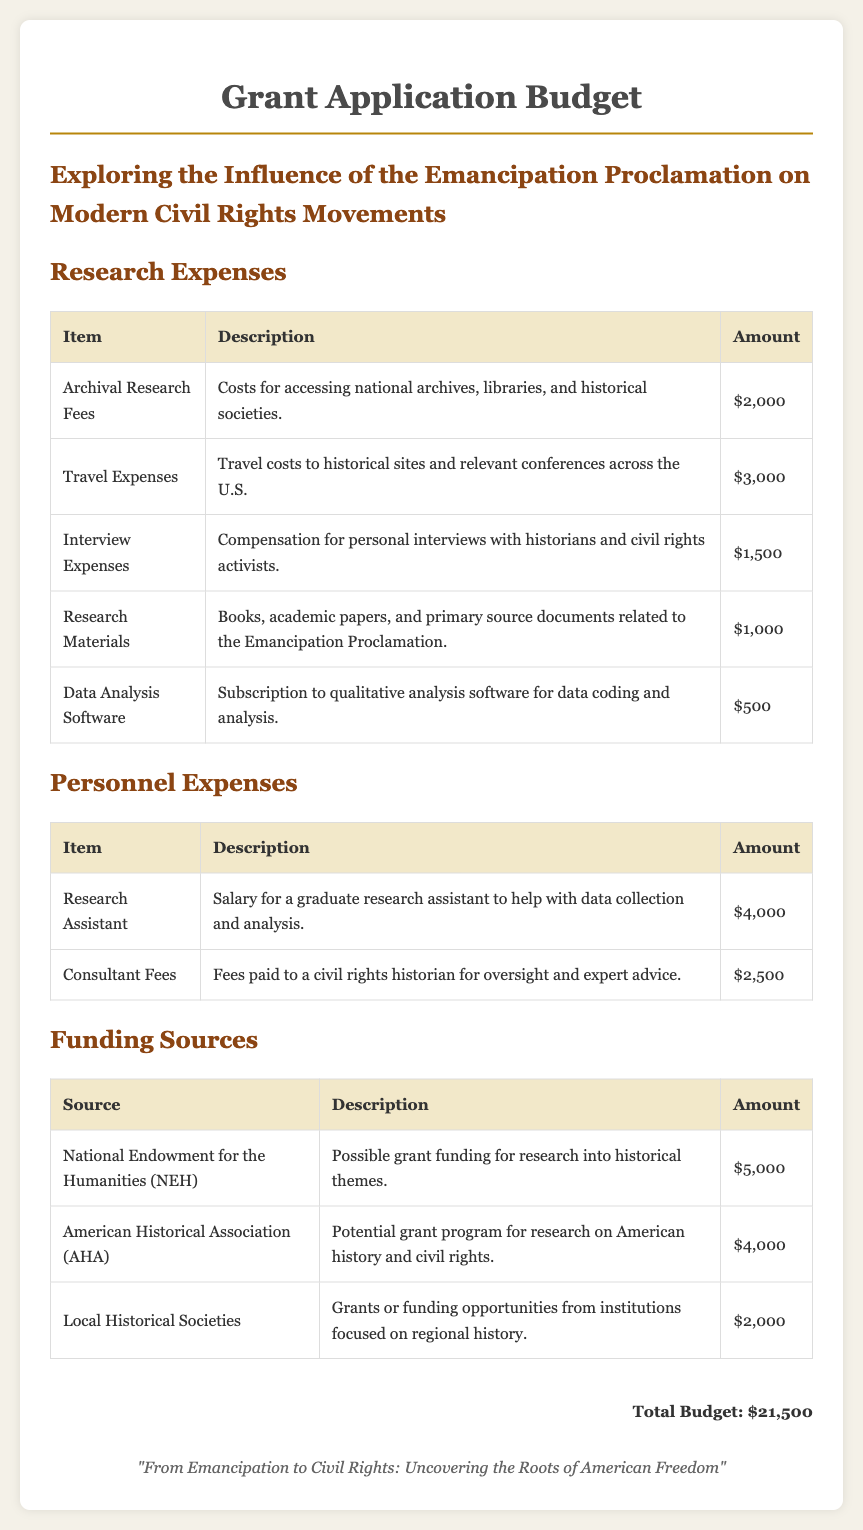What is the total budget? The total budget is presented at the bottom of the document and totals all expenses listed.
Answer: $21,500 How much is allocated for travel expenses? The travel expenses section lists costs associated with travel, which is detailed in that segment.
Answer: $3,000 What is the amount listed for archival research fees? The archival research fees are specifically mentioned as a cost in the research expenses table.
Answer: $2,000 Which funding source is associated with the American Historical Association? The document specifies the funding source and corresponding grants available through the AHA.
Answer: $4,000 How much is the salary for the research assistant? The personnel expenses section breaks down the salary allocations, including that for the research assistant.
Answer: $4,000 What is the amount earmarked for data analysis software? This expense is clearly itemized under research expenses in the budget table.
Answer: $500 How much is budgeted for consultant fees? The consultant fees are noted as a separate line item under personnel expenses.
Answer: $2,500 What type of research is being conducted according to the title? The title of the budget document reflects the focus of the research project.
Answer: Influence of the Emancipation Proclamation on Modern Civil Rights Movements Which organization provides possible grant funding for research into historical themes? This entity is mentioned in the funding sources table.
Answer: National Endowment for the Humanities (NEH) 